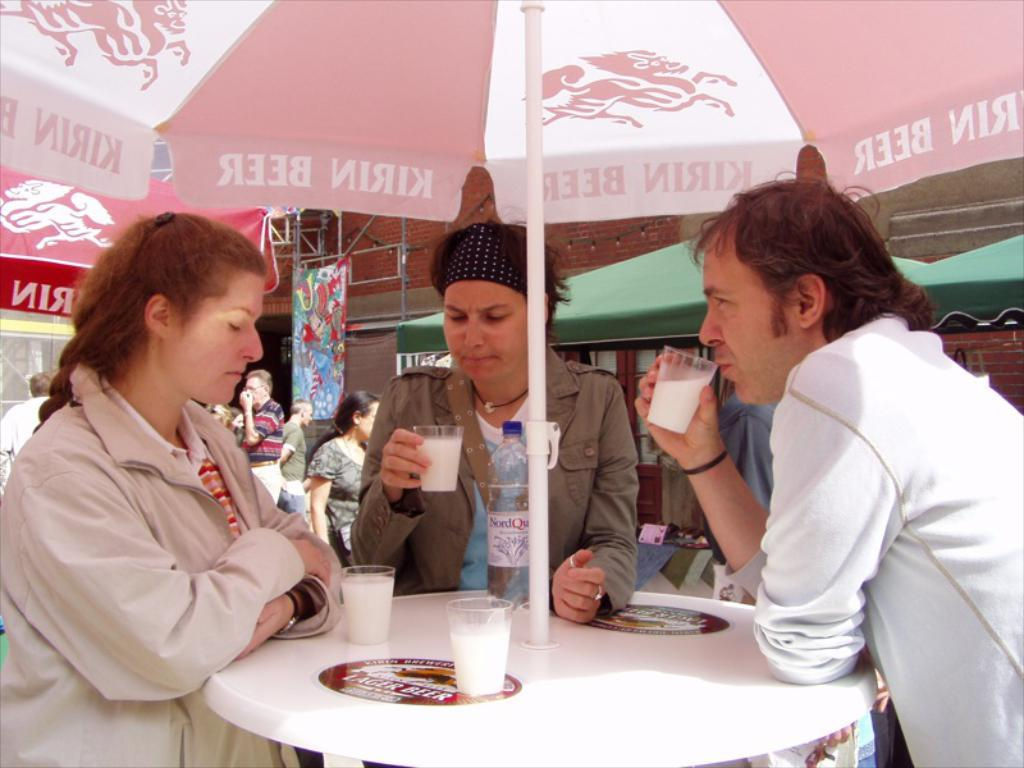How many people are in the image? There are two women and a man in the image, making a total of three individuals. What are the people doing in the image? The three individuals are standing at a table. What are they holding in their hands? Each person is holding a glass of milk. Are there any other glasses of milk visible in the image? Yes, there are glasses of milk on the table. What type of hammer is the man using to extract a tooth from the woman in the image? There is no hammer or tooth extraction taking place in the image. The individuals are simply holding glasses of milk. 